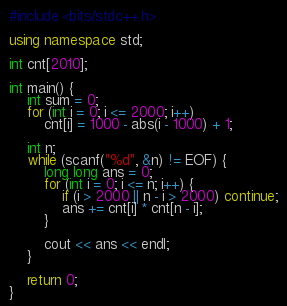Convert code to text. <code><loc_0><loc_0><loc_500><loc_500><_C++_>#include <bits/stdc++.h>

using namespace std;

int cnt[2010];

int main() {
    int sum = 0;
    for (int i = 0; i <= 2000; i++)
        cnt[i] = 1000 - abs(i - 1000) + 1;
    
    int n;
    while (scanf("%d", &n) != EOF) {
        long long ans = 0;
        for (int i = 0; i <= n; i++) {
            if (i > 2000 || n - i > 2000) continue;
            ans += cnt[i] * cnt[n - i];
        }
        
        cout << ans << endl;
    }

    return 0;
}
</code> 